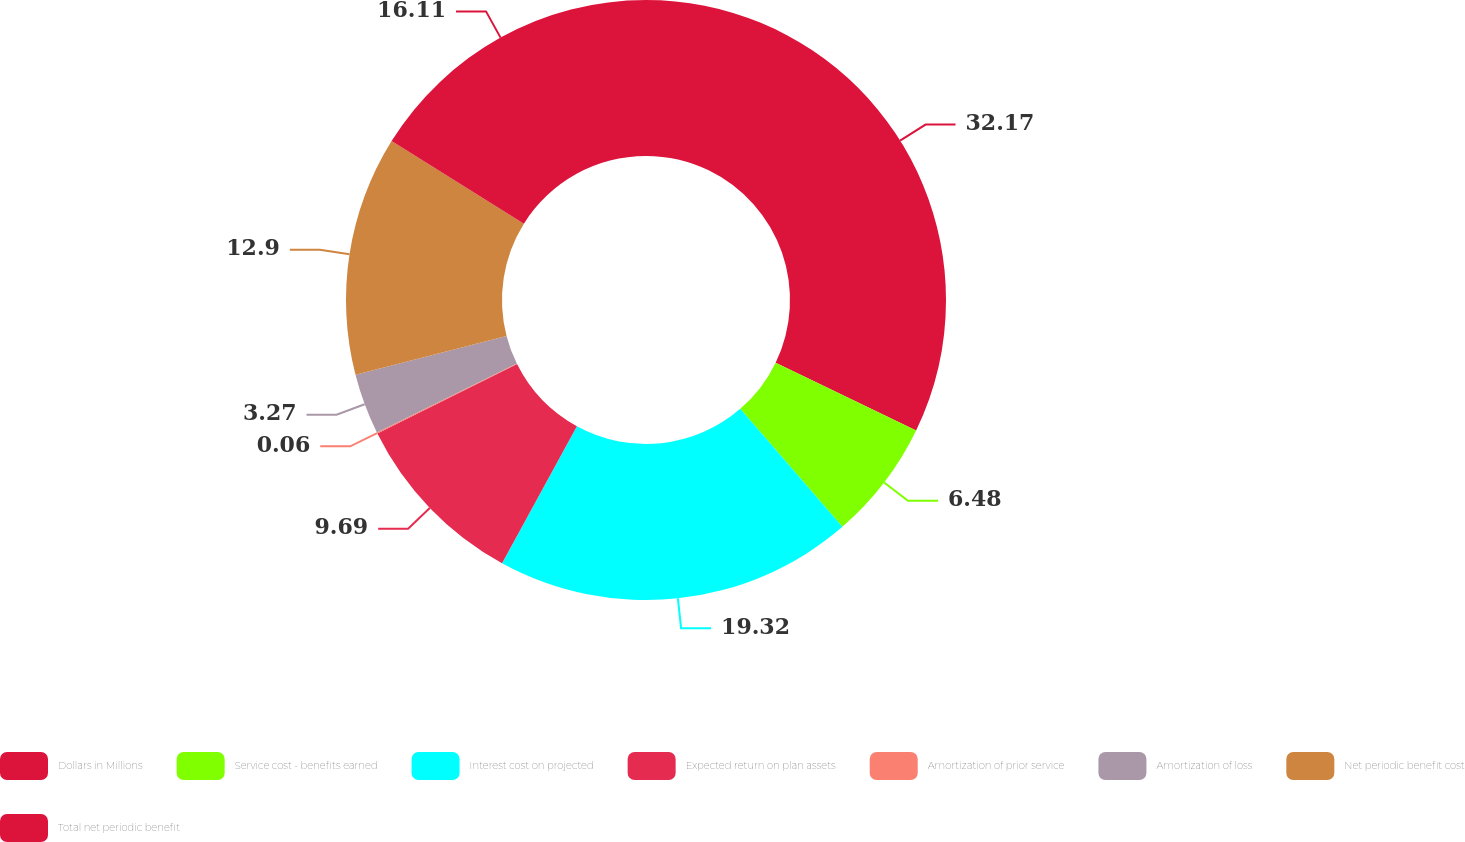Convert chart to OTSL. <chart><loc_0><loc_0><loc_500><loc_500><pie_chart><fcel>Dollars in Millions<fcel>Service cost - benefits earned<fcel>Interest cost on projected<fcel>Expected return on plan assets<fcel>Amortization of prior service<fcel>Amortization of loss<fcel>Net periodic benefit cost<fcel>Total net periodic benefit<nl><fcel>32.16%<fcel>6.48%<fcel>19.32%<fcel>9.69%<fcel>0.06%<fcel>3.27%<fcel>12.9%<fcel>16.11%<nl></chart> 